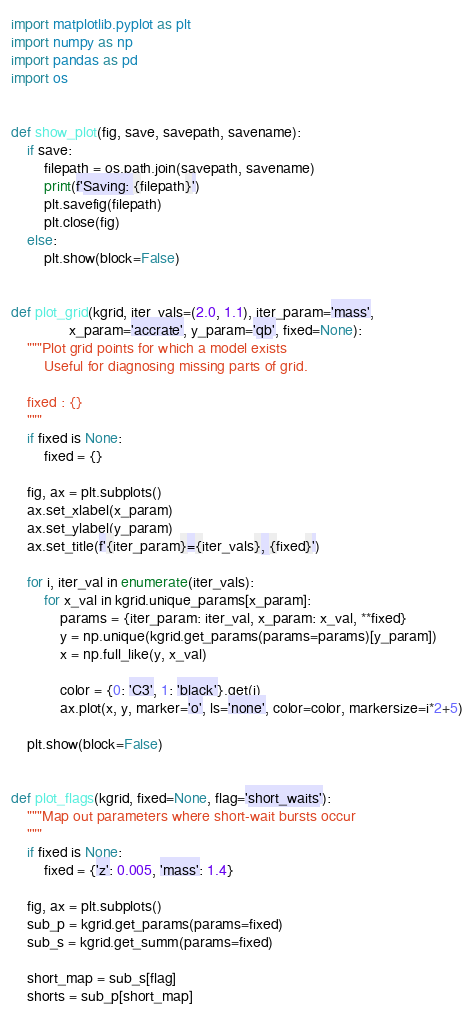<code> <loc_0><loc_0><loc_500><loc_500><_Python_>import matplotlib.pyplot as plt
import numpy as np
import pandas as pd
import os


def show_plot(fig, save, savepath, savename):
    if save:
        filepath = os.path.join(savepath, savename)
        print(f'Saving: {filepath}')
        plt.savefig(filepath)
        plt.close(fig)
    else:
        plt.show(block=False)


def plot_grid(kgrid, iter_vals=(2.0, 1.1), iter_param='mass',
              x_param='accrate', y_param='qb', fixed=None):
    """Plot grid points for which a model exists
        Useful for diagnosing missing parts of grid.

    fixed : {}
    """
    if fixed is None:
        fixed = {}
        
    fig, ax = plt.subplots()
    ax.set_xlabel(x_param)
    ax.set_ylabel(y_param)
    ax.set_title(f'{iter_param}={iter_vals}, {fixed}')

    for i, iter_val in enumerate(iter_vals):
        for x_val in kgrid.unique_params[x_param]:
            params = {iter_param: iter_val, x_param: x_val, **fixed}
            y = np.unique(kgrid.get_params(params=params)[y_param])
            x = np.full_like(y, x_val)

            color = {0: 'C3', 1: 'black'}.get(i)
            ax.plot(x, y, marker='o', ls='none', color=color, markersize=i*2+5)

    plt.show(block=False)


def plot_flags(kgrid, fixed=None, flag='short_waits'):
    """Map out parameters where short-wait bursts occur
    """
    if fixed is None:
        fixed = {'z': 0.005, 'mass': 1.4}

    fig, ax = plt.subplots()
    sub_p = kgrid.get_params(params=fixed)
    sub_s = kgrid.get_summ(params=fixed)

    short_map = sub_s[flag]
    shorts = sub_p[short_map]</code> 